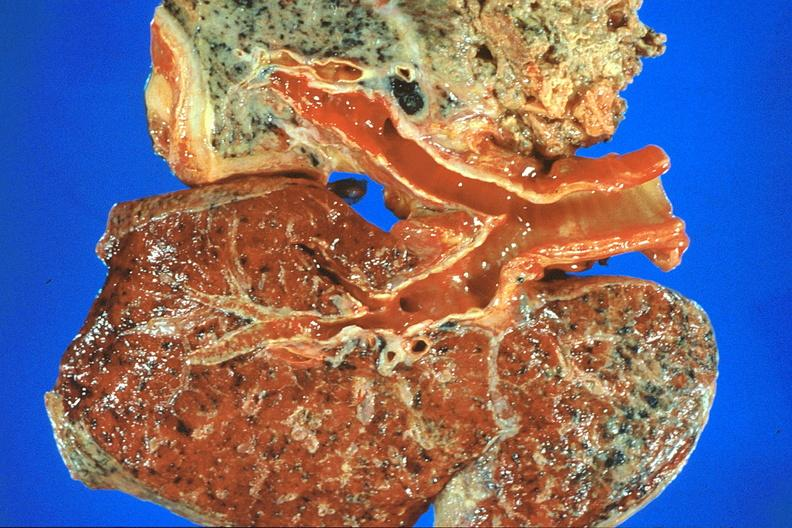where is this?
Answer the question using a single word or phrase. Lung 